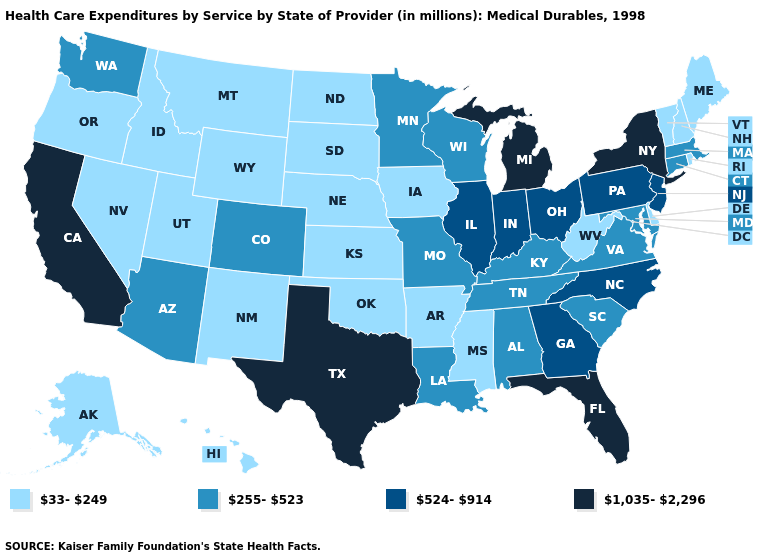Name the states that have a value in the range 255-523?
Be succinct. Alabama, Arizona, Colorado, Connecticut, Kentucky, Louisiana, Maryland, Massachusetts, Minnesota, Missouri, South Carolina, Tennessee, Virginia, Washington, Wisconsin. What is the value of Idaho?
Write a very short answer. 33-249. What is the value of Kansas?
Short answer required. 33-249. Name the states that have a value in the range 255-523?
Keep it brief. Alabama, Arizona, Colorado, Connecticut, Kentucky, Louisiana, Maryland, Massachusetts, Minnesota, Missouri, South Carolina, Tennessee, Virginia, Washington, Wisconsin. Does Kentucky have the lowest value in the South?
Quick response, please. No. Among the states that border Rhode Island , which have the highest value?
Concise answer only. Connecticut, Massachusetts. What is the value of Minnesota?
Give a very brief answer. 255-523. Does New Jersey have the lowest value in the Northeast?
Write a very short answer. No. What is the value of South Dakota?
Write a very short answer. 33-249. What is the value of Indiana?
Write a very short answer. 524-914. What is the value of Alaska?
Keep it brief. 33-249. What is the lowest value in states that border Illinois?
Write a very short answer. 33-249. Is the legend a continuous bar?
Keep it brief. No. What is the value of North Dakota?
Concise answer only. 33-249. Among the states that border West Virginia , does Maryland have the highest value?
Concise answer only. No. 